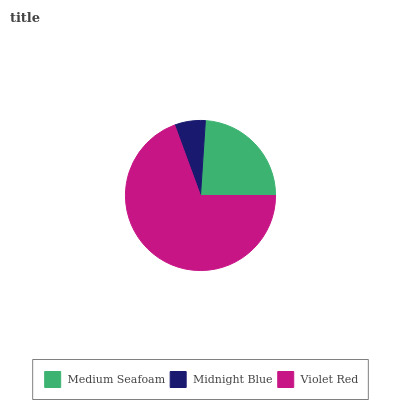Is Midnight Blue the minimum?
Answer yes or no. Yes. Is Violet Red the maximum?
Answer yes or no. Yes. Is Violet Red the minimum?
Answer yes or no. No. Is Midnight Blue the maximum?
Answer yes or no. No. Is Violet Red greater than Midnight Blue?
Answer yes or no. Yes. Is Midnight Blue less than Violet Red?
Answer yes or no. Yes. Is Midnight Blue greater than Violet Red?
Answer yes or no. No. Is Violet Red less than Midnight Blue?
Answer yes or no. No. Is Medium Seafoam the high median?
Answer yes or no. Yes. Is Medium Seafoam the low median?
Answer yes or no. Yes. Is Midnight Blue the high median?
Answer yes or no. No. Is Violet Red the low median?
Answer yes or no. No. 